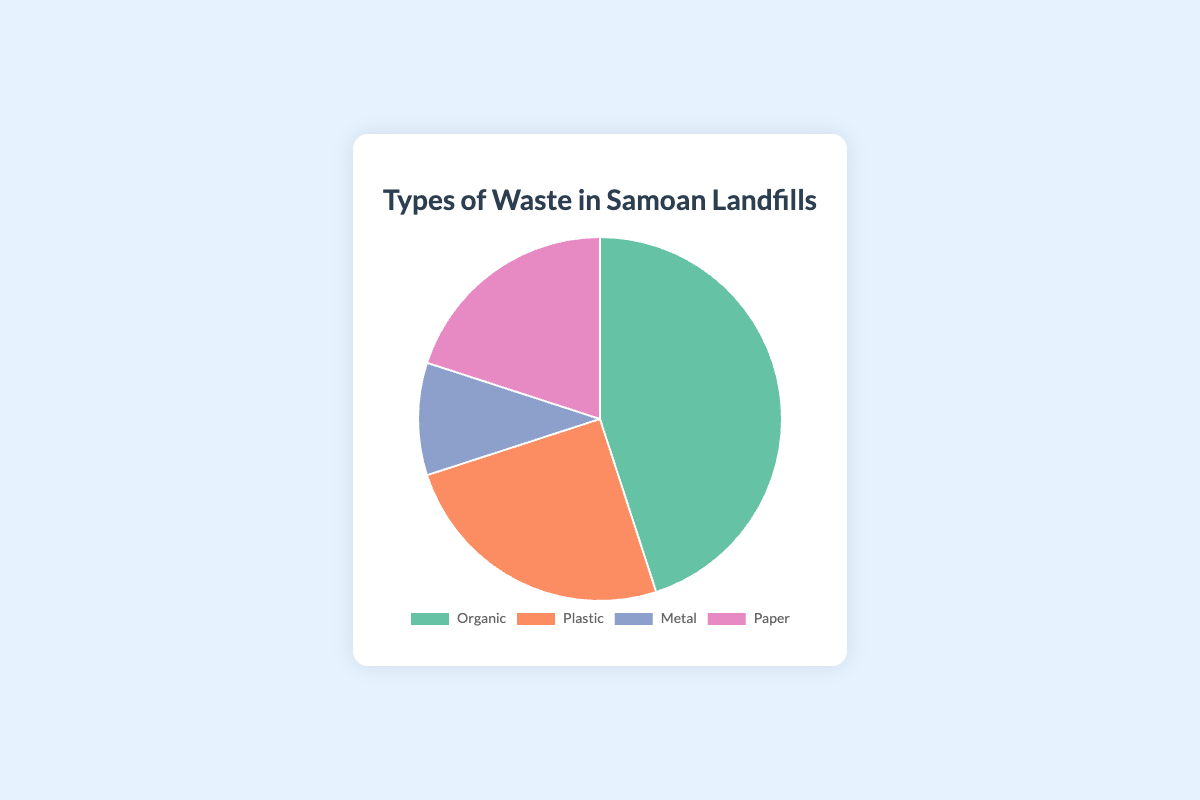Which type of waste occupies the largest percentage in Samoan landfills? The pie chart shows the distribution of different types of waste. Organic waste occupies the largest percentage at 45%.
Answer: Organic Which type of waste occupies the smallest percentage in Samoan landfills? By viewing the pie chart, it is clear that Metal waste has the smallest percentage at 10%.
Answer: Metal How do the percentages of Organic and Plastic waste combined compare to Paper waste? Organic waste is 45% and Plastic waste is 25%. Adding them together gives 45% + 25% = 70%. Paper waste is 20%. 70% is greater than 20%.
Answer: Organic and Plastic combined are greater What is the difference in percentage between Organic and Paper waste? The percentage of Organic waste is 45% and Paper waste is 20%. Subtracting these values gives 45% - 20% = 25%.
Answer: 25% What is the total percentage of Paper and Metal waste? Paper waste is 20% and Metal waste is 10%. Adding them together gives 20% + 10% = 30%.
Answer: 30% Which type of waste is represented by the color green in the pie chart? The color green in the pie chart represents Organic waste, which is 45%.
Answer: Organic How does the percentage of Plastic waste compare to Metal waste? The percentage of Plastic waste is 25% and Metal waste is 10%. 25% is greater than 10%.
Answer: Plastic is greater If you were to combine the Organic and Paper waste percentages, what fraction of the total do they represent? Organic waste is 45% and Paper waste is 20%. Combined they are 65%. Hence, 65/100 = 13/20.
Answer: 13/20 What percentage of the waste is neither Plastic nor Metal? The percentages of Plastic and Metal waste are 25% and 10% respectively. Adding them gives 25% + 10% = 35%. Subtracting from 100% gives 100% - 35% = 65%.
Answer: 65% Comparing the colors of the segments, which waste type is represented by a pink color? The pink color in the pie chart represents Paper waste, which is 20%.
Answer: Paper 